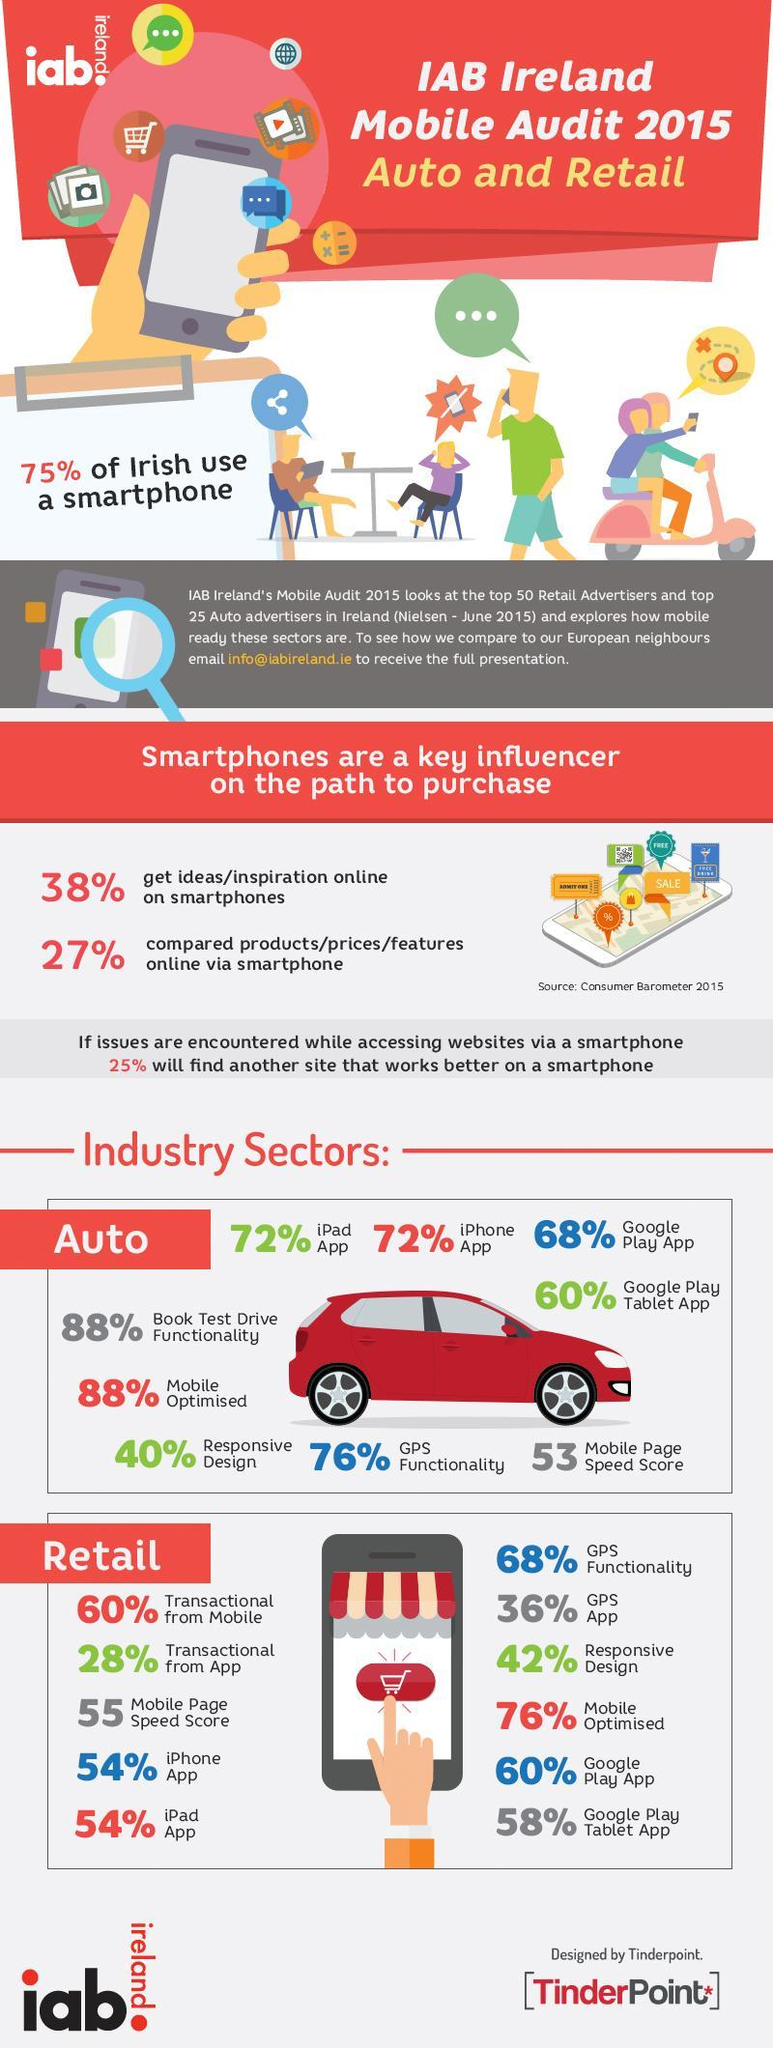In which sector 88% websites are mobile optimised?
Answer the question with a short phrase. Auto In which sector 76% websites are mobile optimised? Retail What percent of websites facilitate transactions via mobile in the retail sector? 60% In retail sector, what percent of websites support Google Play Tablet App? 58% In retail sector, what percent of websites support GPS App? 36% In which sector is the responsive design 40%? Auto In which industrial sector is the mobile page speed score 53? Auto 